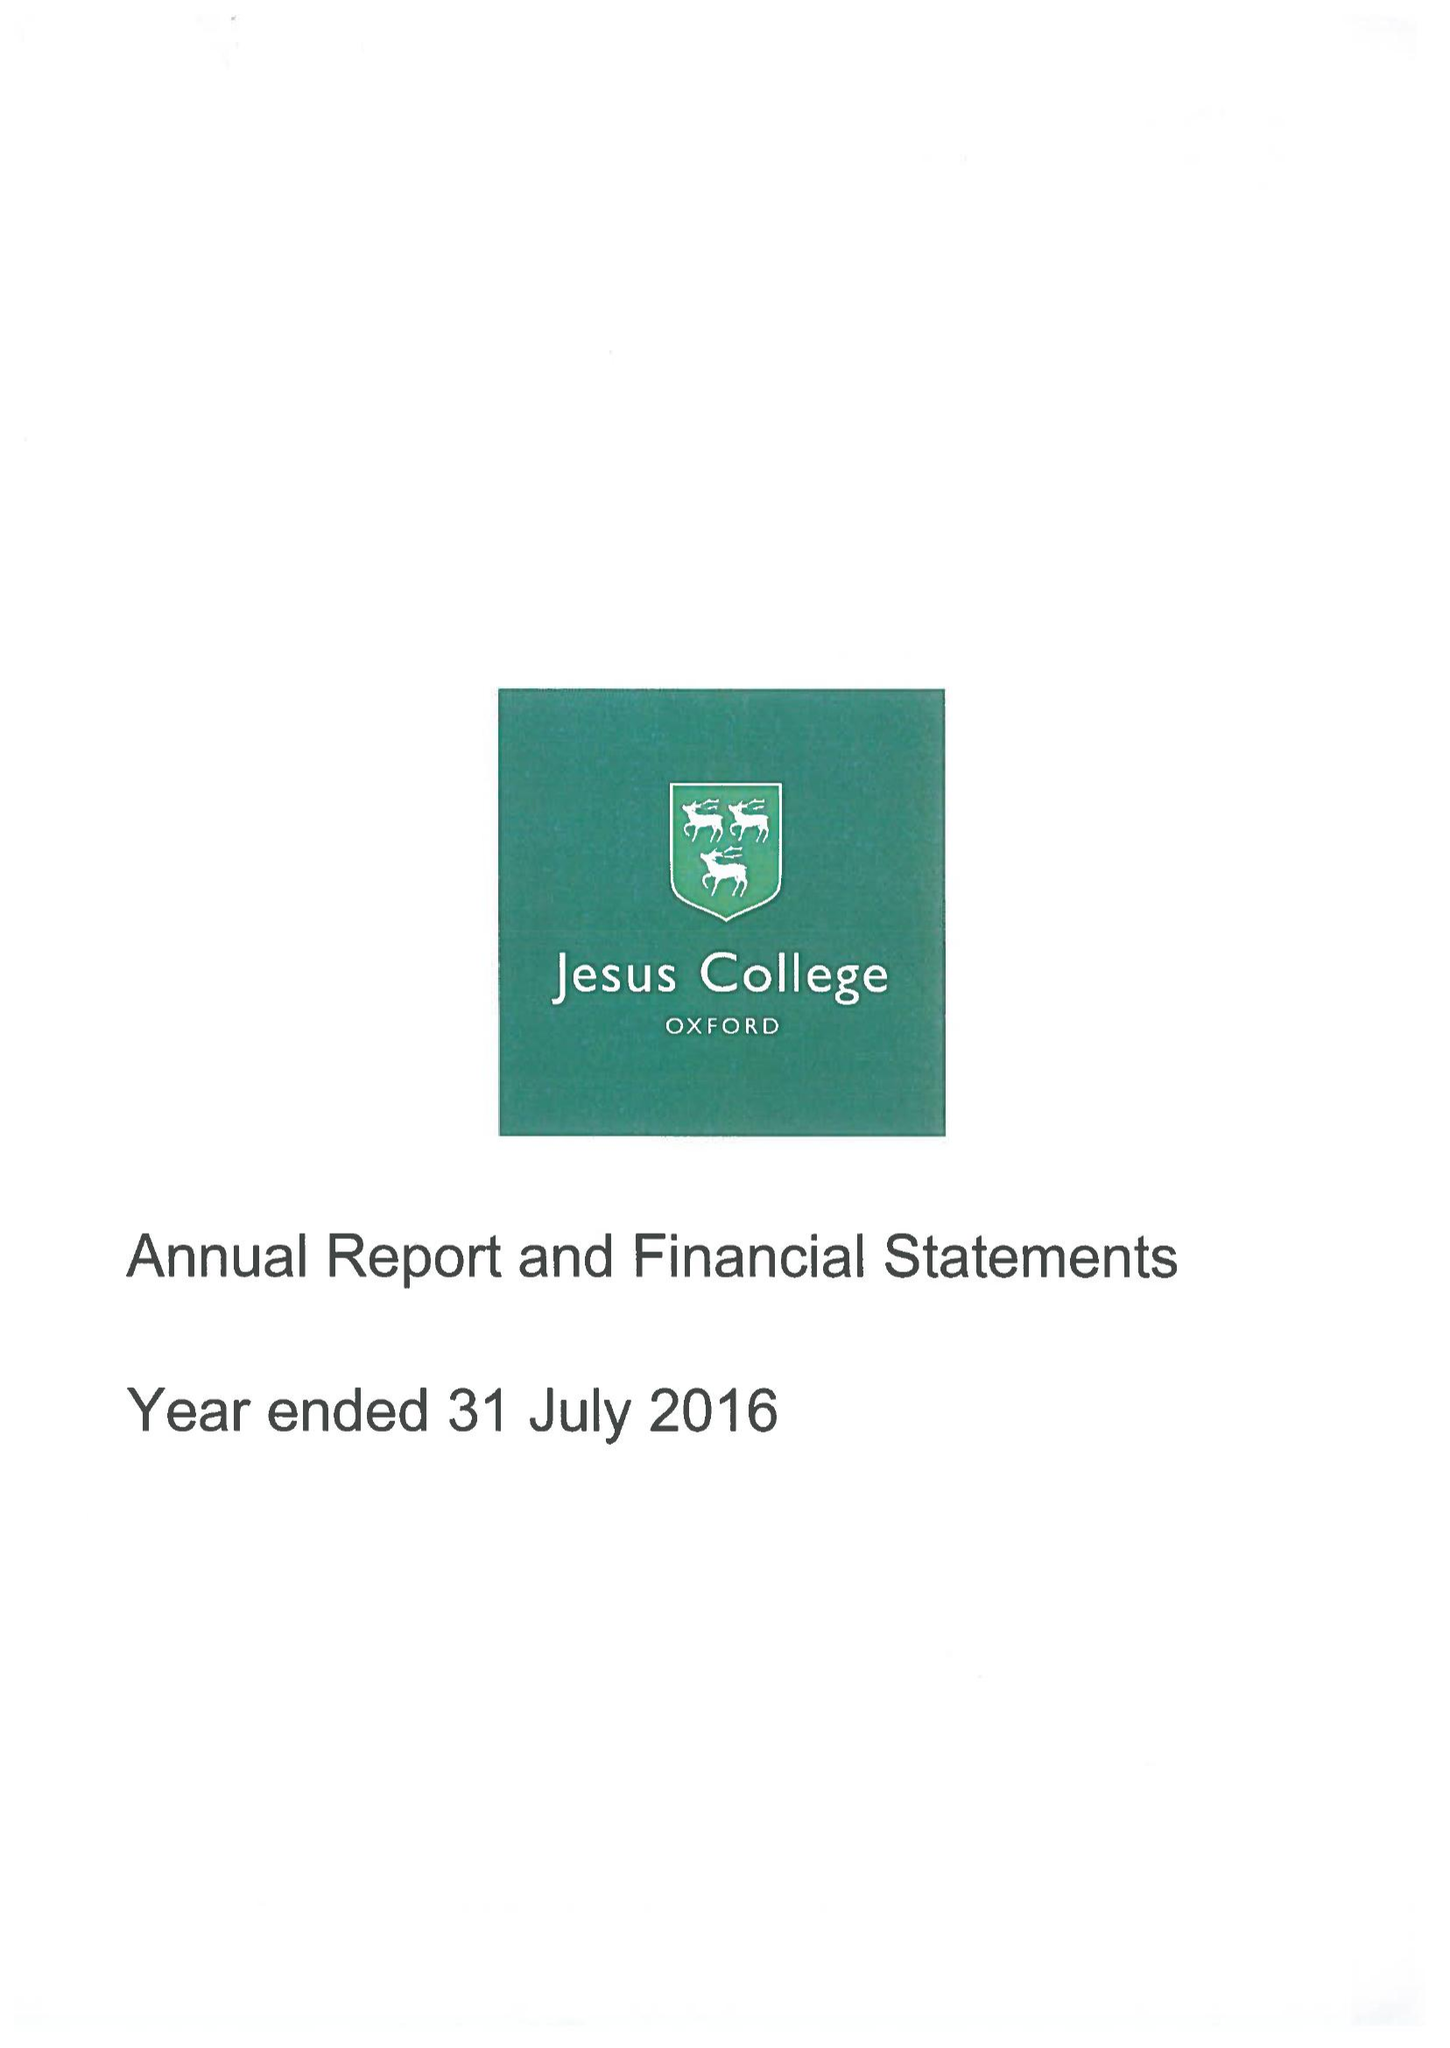What is the value for the address__postcode?
Answer the question using a single word or phrase. OX1 3DW 